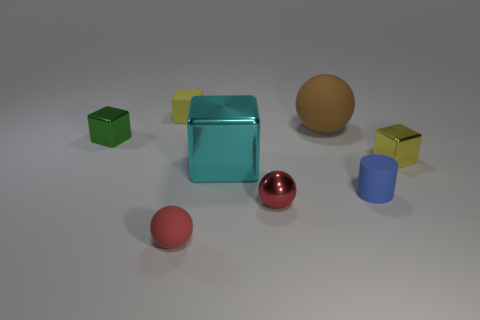What material is the cyan cube?
Keep it short and to the point. Metal. Are there any big yellow metallic cubes?
Provide a succinct answer. No. What color is the sphere left of the large cyan metallic block?
Keep it short and to the point. Red. How many cyan metal blocks are on the right side of the tiny yellow thing behind the small metal cube to the right of the small green metallic cube?
Your answer should be compact. 1. What material is the cube that is left of the yellow metal block and right of the yellow rubber cube?
Give a very brief answer. Metal. Is the small blue object made of the same material as the block that is to the right of the red shiny ball?
Make the answer very short. No. Is the number of green metallic things that are on the left side of the brown rubber sphere greater than the number of large shiny objects that are to the left of the small green metallic object?
Offer a terse response. Yes. What is the shape of the red rubber object?
Keep it short and to the point. Sphere. Does the tiny sphere left of the large block have the same material as the yellow thing that is left of the cyan metallic cube?
Provide a short and direct response. Yes. There is a metal object on the left side of the tiny yellow matte cube; what shape is it?
Your answer should be very brief. Cube. 